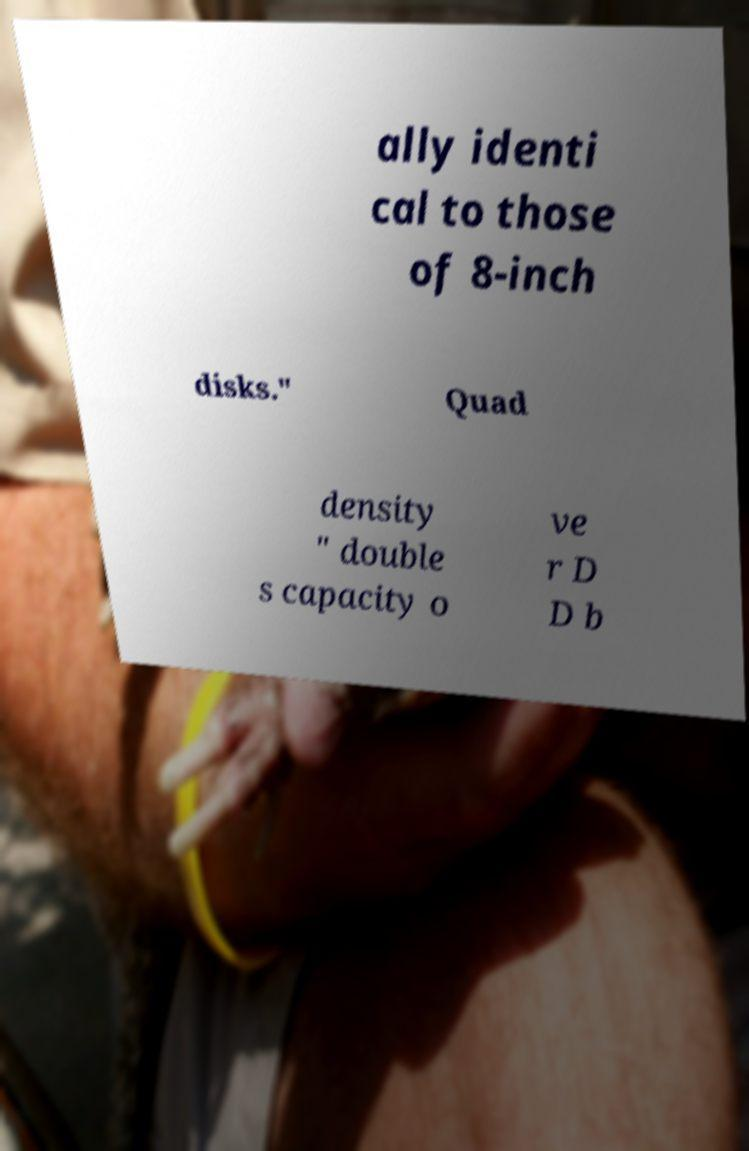Could you extract and type out the text from this image? ally identi cal to those of 8-inch disks." Quad density " double s capacity o ve r D D b 